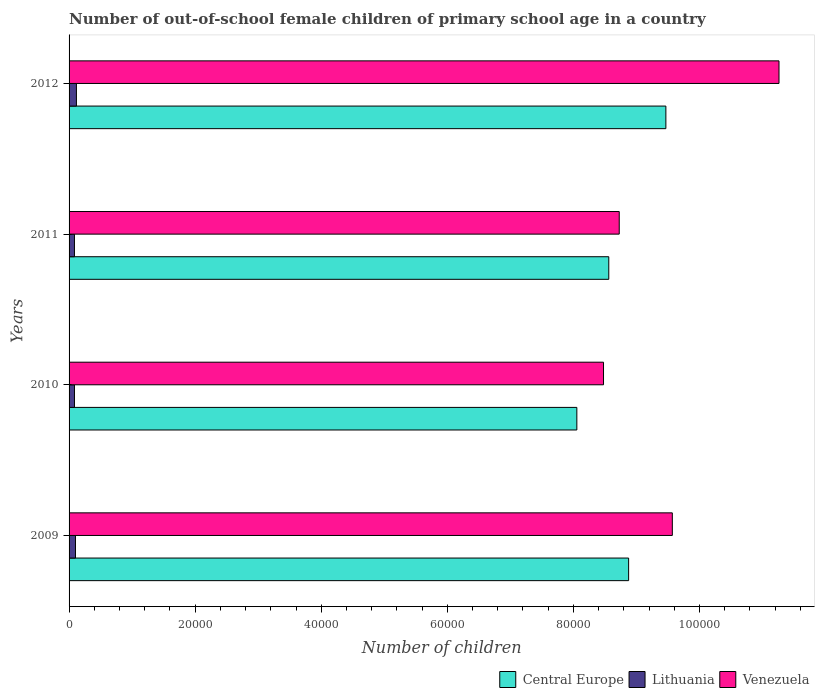How many different coloured bars are there?
Provide a succinct answer. 3. How many groups of bars are there?
Offer a very short reply. 4. Are the number of bars per tick equal to the number of legend labels?
Make the answer very short. Yes. Are the number of bars on each tick of the Y-axis equal?
Provide a short and direct response. Yes. How many bars are there on the 4th tick from the bottom?
Give a very brief answer. 3. What is the label of the 3rd group of bars from the top?
Give a very brief answer. 2010. In how many cases, is the number of bars for a given year not equal to the number of legend labels?
Ensure brevity in your answer.  0. What is the number of out-of-school female children in Central Europe in 2009?
Offer a terse response. 8.88e+04. Across all years, what is the maximum number of out-of-school female children in Central Europe?
Your answer should be compact. 9.47e+04. Across all years, what is the minimum number of out-of-school female children in Lithuania?
Your answer should be very brief. 855. What is the total number of out-of-school female children in Venezuela in the graph?
Your response must be concise. 3.80e+05. What is the difference between the number of out-of-school female children in Lithuania in 2010 and that in 2012?
Make the answer very short. -310. What is the difference between the number of out-of-school female children in Lithuania in 2009 and the number of out-of-school female children in Venezuela in 2011?
Give a very brief answer. -8.63e+04. What is the average number of out-of-school female children in Venezuela per year?
Your response must be concise. 9.51e+04. In the year 2009, what is the difference between the number of out-of-school female children in Venezuela and number of out-of-school female children in Lithuania?
Your response must be concise. 9.47e+04. In how many years, is the number of out-of-school female children in Central Europe greater than 80000 ?
Provide a succinct answer. 4. What is the ratio of the number of out-of-school female children in Lithuania in 2009 to that in 2012?
Give a very brief answer. 0.87. Is the number of out-of-school female children in Venezuela in 2010 less than that in 2011?
Provide a succinct answer. Yes. What is the difference between the highest and the second highest number of out-of-school female children in Central Europe?
Make the answer very short. 5908. What is the difference between the highest and the lowest number of out-of-school female children in Lithuania?
Give a very brief answer. 312. What does the 3rd bar from the top in 2009 represents?
Give a very brief answer. Central Europe. What does the 2nd bar from the bottom in 2011 represents?
Offer a terse response. Lithuania. How many years are there in the graph?
Make the answer very short. 4. What is the difference between two consecutive major ticks on the X-axis?
Make the answer very short. 2.00e+04. Does the graph contain any zero values?
Give a very brief answer. No. Does the graph contain grids?
Make the answer very short. No. Where does the legend appear in the graph?
Keep it short and to the point. Bottom right. How many legend labels are there?
Your answer should be compact. 3. How are the legend labels stacked?
Offer a very short reply. Horizontal. What is the title of the graph?
Your answer should be compact. Number of out-of-school female children of primary school age in a country. What is the label or title of the X-axis?
Give a very brief answer. Number of children. What is the label or title of the Y-axis?
Your answer should be compact. Years. What is the Number of children in Central Europe in 2009?
Ensure brevity in your answer.  8.88e+04. What is the Number of children of Lithuania in 2009?
Ensure brevity in your answer.  1017. What is the Number of children of Venezuela in 2009?
Make the answer very short. 9.57e+04. What is the Number of children of Central Europe in 2010?
Make the answer very short. 8.06e+04. What is the Number of children of Lithuania in 2010?
Give a very brief answer. 857. What is the Number of children of Venezuela in 2010?
Provide a short and direct response. 8.48e+04. What is the Number of children of Central Europe in 2011?
Keep it short and to the point. 8.56e+04. What is the Number of children in Lithuania in 2011?
Keep it short and to the point. 855. What is the Number of children of Venezuela in 2011?
Provide a short and direct response. 8.73e+04. What is the Number of children of Central Europe in 2012?
Provide a short and direct response. 9.47e+04. What is the Number of children in Lithuania in 2012?
Give a very brief answer. 1167. What is the Number of children in Venezuela in 2012?
Provide a short and direct response. 1.13e+05. Across all years, what is the maximum Number of children in Central Europe?
Your answer should be compact. 9.47e+04. Across all years, what is the maximum Number of children in Lithuania?
Keep it short and to the point. 1167. Across all years, what is the maximum Number of children of Venezuela?
Your response must be concise. 1.13e+05. Across all years, what is the minimum Number of children of Central Europe?
Offer a terse response. 8.06e+04. Across all years, what is the minimum Number of children of Lithuania?
Your answer should be very brief. 855. Across all years, what is the minimum Number of children in Venezuela?
Provide a short and direct response. 8.48e+04. What is the total Number of children in Central Europe in the graph?
Provide a succinct answer. 3.50e+05. What is the total Number of children of Lithuania in the graph?
Keep it short and to the point. 3896. What is the total Number of children in Venezuela in the graph?
Your answer should be compact. 3.80e+05. What is the difference between the Number of children in Central Europe in 2009 and that in 2010?
Ensure brevity in your answer.  8214. What is the difference between the Number of children in Lithuania in 2009 and that in 2010?
Your response must be concise. 160. What is the difference between the Number of children in Venezuela in 2009 and that in 2010?
Give a very brief answer. 1.09e+04. What is the difference between the Number of children in Central Europe in 2009 and that in 2011?
Offer a terse response. 3149. What is the difference between the Number of children in Lithuania in 2009 and that in 2011?
Your response must be concise. 162. What is the difference between the Number of children in Venezuela in 2009 and that in 2011?
Offer a very short reply. 8421. What is the difference between the Number of children of Central Europe in 2009 and that in 2012?
Give a very brief answer. -5908. What is the difference between the Number of children in Lithuania in 2009 and that in 2012?
Offer a terse response. -150. What is the difference between the Number of children in Venezuela in 2009 and that in 2012?
Your response must be concise. -1.69e+04. What is the difference between the Number of children of Central Europe in 2010 and that in 2011?
Your answer should be very brief. -5065. What is the difference between the Number of children of Lithuania in 2010 and that in 2011?
Make the answer very short. 2. What is the difference between the Number of children in Venezuela in 2010 and that in 2011?
Offer a terse response. -2494. What is the difference between the Number of children in Central Europe in 2010 and that in 2012?
Your answer should be compact. -1.41e+04. What is the difference between the Number of children of Lithuania in 2010 and that in 2012?
Your answer should be compact. -310. What is the difference between the Number of children in Venezuela in 2010 and that in 2012?
Give a very brief answer. -2.78e+04. What is the difference between the Number of children of Central Europe in 2011 and that in 2012?
Keep it short and to the point. -9057. What is the difference between the Number of children of Lithuania in 2011 and that in 2012?
Your response must be concise. -312. What is the difference between the Number of children of Venezuela in 2011 and that in 2012?
Give a very brief answer. -2.53e+04. What is the difference between the Number of children of Central Europe in 2009 and the Number of children of Lithuania in 2010?
Provide a short and direct response. 8.79e+04. What is the difference between the Number of children in Central Europe in 2009 and the Number of children in Venezuela in 2010?
Keep it short and to the point. 3983. What is the difference between the Number of children in Lithuania in 2009 and the Number of children in Venezuela in 2010?
Provide a succinct answer. -8.38e+04. What is the difference between the Number of children in Central Europe in 2009 and the Number of children in Lithuania in 2011?
Offer a terse response. 8.79e+04. What is the difference between the Number of children of Central Europe in 2009 and the Number of children of Venezuela in 2011?
Give a very brief answer. 1489. What is the difference between the Number of children of Lithuania in 2009 and the Number of children of Venezuela in 2011?
Keep it short and to the point. -8.63e+04. What is the difference between the Number of children of Central Europe in 2009 and the Number of children of Lithuania in 2012?
Your answer should be compact. 8.76e+04. What is the difference between the Number of children in Central Europe in 2009 and the Number of children in Venezuela in 2012?
Make the answer very short. -2.39e+04. What is the difference between the Number of children in Lithuania in 2009 and the Number of children in Venezuela in 2012?
Give a very brief answer. -1.12e+05. What is the difference between the Number of children in Central Europe in 2010 and the Number of children in Lithuania in 2011?
Offer a terse response. 7.97e+04. What is the difference between the Number of children in Central Europe in 2010 and the Number of children in Venezuela in 2011?
Make the answer very short. -6725. What is the difference between the Number of children in Lithuania in 2010 and the Number of children in Venezuela in 2011?
Keep it short and to the point. -8.64e+04. What is the difference between the Number of children in Central Europe in 2010 and the Number of children in Lithuania in 2012?
Make the answer very short. 7.94e+04. What is the difference between the Number of children in Central Europe in 2010 and the Number of children in Venezuela in 2012?
Provide a short and direct response. -3.21e+04. What is the difference between the Number of children of Lithuania in 2010 and the Number of children of Venezuela in 2012?
Your answer should be compact. -1.12e+05. What is the difference between the Number of children in Central Europe in 2011 and the Number of children in Lithuania in 2012?
Your answer should be compact. 8.44e+04. What is the difference between the Number of children of Central Europe in 2011 and the Number of children of Venezuela in 2012?
Your response must be concise. -2.70e+04. What is the difference between the Number of children of Lithuania in 2011 and the Number of children of Venezuela in 2012?
Your answer should be very brief. -1.12e+05. What is the average Number of children in Central Europe per year?
Provide a succinct answer. 8.74e+04. What is the average Number of children in Lithuania per year?
Ensure brevity in your answer.  974. What is the average Number of children of Venezuela per year?
Keep it short and to the point. 9.51e+04. In the year 2009, what is the difference between the Number of children of Central Europe and Number of children of Lithuania?
Your response must be concise. 8.77e+04. In the year 2009, what is the difference between the Number of children of Central Europe and Number of children of Venezuela?
Offer a terse response. -6932. In the year 2009, what is the difference between the Number of children of Lithuania and Number of children of Venezuela?
Your response must be concise. -9.47e+04. In the year 2010, what is the difference between the Number of children of Central Europe and Number of children of Lithuania?
Your answer should be very brief. 7.97e+04. In the year 2010, what is the difference between the Number of children of Central Europe and Number of children of Venezuela?
Your response must be concise. -4231. In the year 2010, what is the difference between the Number of children of Lithuania and Number of children of Venezuela?
Provide a succinct answer. -8.39e+04. In the year 2011, what is the difference between the Number of children in Central Europe and Number of children in Lithuania?
Ensure brevity in your answer.  8.48e+04. In the year 2011, what is the difference between the Number of children in Central Europe and Number of children in Venezuela?
Offer a terse response. -1660. In the year 2011, what is the difference between the Number of children in Lithuania and Number of children in Venezuela?
Ensure brevity in your answer.  -8.64e+04. In the year 2012, what is the difference between the Number of children of Central Europe and Number of children of Lithuania?
Offer a terse response. 9.35e+04. In the year 2012, what is the difference between the Number of children in Central Europe and Number of children in Venezuela?
Provide a succinct answer. -1.79e+04. In the year 2012, what is the difference between the Number of children of Lithuania and Number of children of Venezuela?
Provide a short and direct response. -1.11e+05. What is the ratio of the Number of children in Central Europe in 2009 to that in 2010?
Ensure brevity in your answer.  1.1. What is the ratio of the Number of children in Lithuania in 2009 to that in 2010?
Offer a very short reply. 1.19. What is the ratio of the Number of children in Venezuela in 2009 to that in 2010?
Offer a terse response. 1.13. What is the ratio of the Number of children in Central Europe in 2009 to that in 2011?
Make the answer very short. 1.04. What is the ratio of the Number of children of Lithuania in 2009 to that in 2011?
Keep it short and to the point. 1.19. What is the ratio of the Number of children in Venezuela in 2009 to that in 2011?
Provide a short and direct response. 1.1. What is the ratio of the Number of children of Central Europe in 2009 to that in 2012?
Make the answer very short. 0.94. What is the ratio of the Number of children of Lithuania in 2009 to that in 2012?
Give a very brief answer. 0.87. What is the ratio of the Number of children of Venezuela in 2009 to that in 2012?
Provide a short and direct response. 0.85. What is the ratio of the Number of children in Central Europe in 2010 to that in 2011?
Offer a very short reply. 0.94. What is the ratio of the Number of children in Lithuania in 2010 to that in 2011?
Your answer should be very brief. 1. What is the ratio of the Number of children in Venezuela in 2010 to that in 2011?
Provide a short and direct response. 0.97. What is the ratio of the Number of children in Central Europe in 2010 to that in 2012?
Offer a very short reply. 0.85. What is the ratio of the Number of children in Lithuania in 2010 to that in 2012?
Offer a very short reply. 0.73. What is the ratio of the Number of children of Venezuela in 2010 to that in 2012?
Your response must be concise. 0.75. What is the ratio of the Number of children in Central Europe in 2011 to that in 2012?
Give a very brief answer. 0.9. What is the ratio of the Number of children in Lithuania in 2011 to that in 2012?
Your answer should be compact. 0.73. What is the ratio of the Number of children of Venezuela in 2011 to that in 2012?
Ensure brevity in your answer.  0.78. What is the difference between the highest and the second highest Number of children in Central Europe?
Make the answer very short. 5908. What is the difference between the highest and the second highest Number of children in Lithuania?
Provide a short and direct response. 150. What is the difference between the highest and the second highest Number of children in Venezuela?
Ensure brevity in your answer.  1.69e+04. What is the difference between the highest and the lowest Number of children of Central Europe?
Offer a very short reply. 1.41e+04. What is the difference between the highest and the lowest Number of children in Lithuania?
Ensure brevity in your answer.  312. What is the difference between the highest and the lowest Number of children of Venezuela?
Offer a terse response. 2.78e+04. 